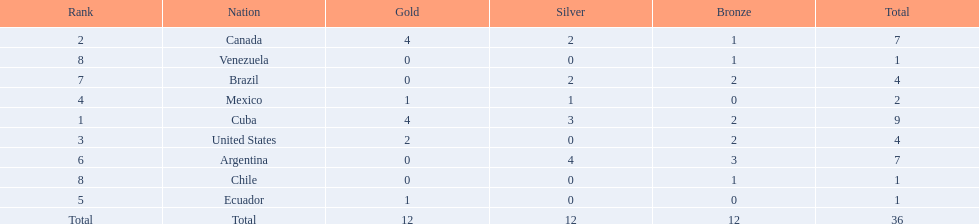What were all of the nations involved in the canoeing at the 2011 pan american games? Cuba, Canada, United States, Mexico, Ecuador, Argentina, Brazil, Chile, Venezuela, Total. Of these, which had a numbered rank? Cuba, Canada, United States, Mexico, Ecuador, Argentina, Brazil, Chile, Venezuela. From these, which had the highest number of bronze? Argentina. 